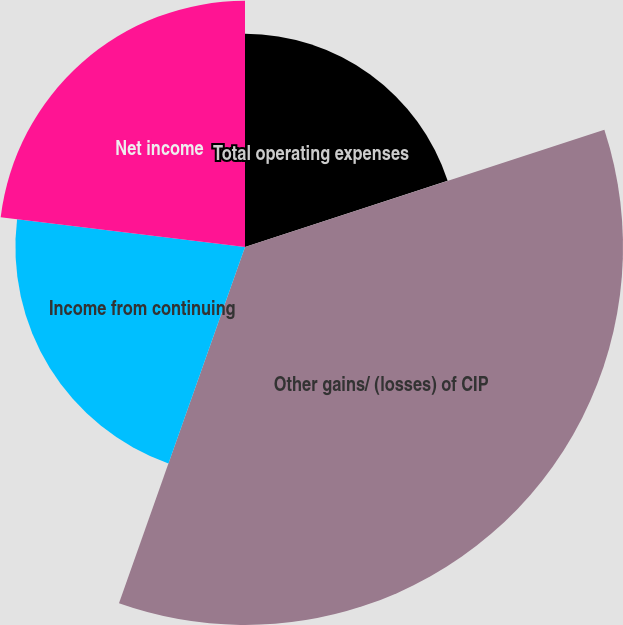Convert chart. <chart><loc_0><loc_0><loc_500><loc_500><pie_chart><fcel>Total operating expenses<fcel>Other gains/ (losses) of CIP<fcel>Income from continuing<fcel>Net income<nl><fcel>19.98%<fcel>35.43%<fcel>21.52%<fcel>23.07%<nl></chart> 